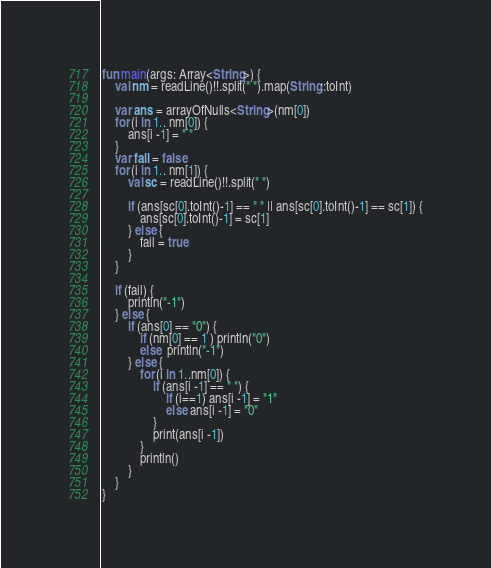<code> <loc_0><loc_0><loc_500><loc_500><_Kotlin_>fun main(args: Array<String>) {
    val nm = readLine()!!.split(" ").map(String::toInt)

    var ans = arrayOfNulls<String>(nm[0])
    for (i in 1.. nm[0]) {
        ans[i -1] = " "
    }
    var fail = false
    for (i in 1.. nm[1]) {
        val sc = readLine()!!.split(" ")

        if (ans[sc[0].toInt()-1] == " " || ans[sc[0].toInt()-1] == sc[1]) {
            ans[sc[0].toInt()-1] = sc[1]
        } else {
            fail = true
        }
    }

    if (fail) {
        println("-1")
    } else {
        if (ans[0] == "0") {
            if (nm[0] == 1 ) println("0")
            else  println("-1")
        } else {
            for (i in 1..nm[0]) {
                if (ans[i -1] == " ") {
                    if (i==1) ans[i -1] = "1"
                    else ans[i -1] = "0"
                }
                print(ans[i -1])
            }
            println()
        }
    }
}
</code> 